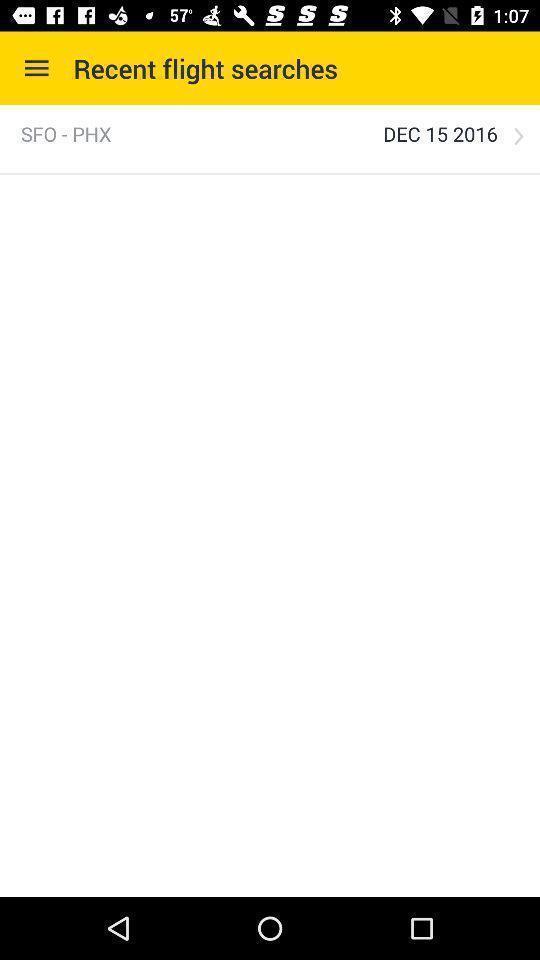Summarize the information in this screenshot. Window displaying a flight search page. 